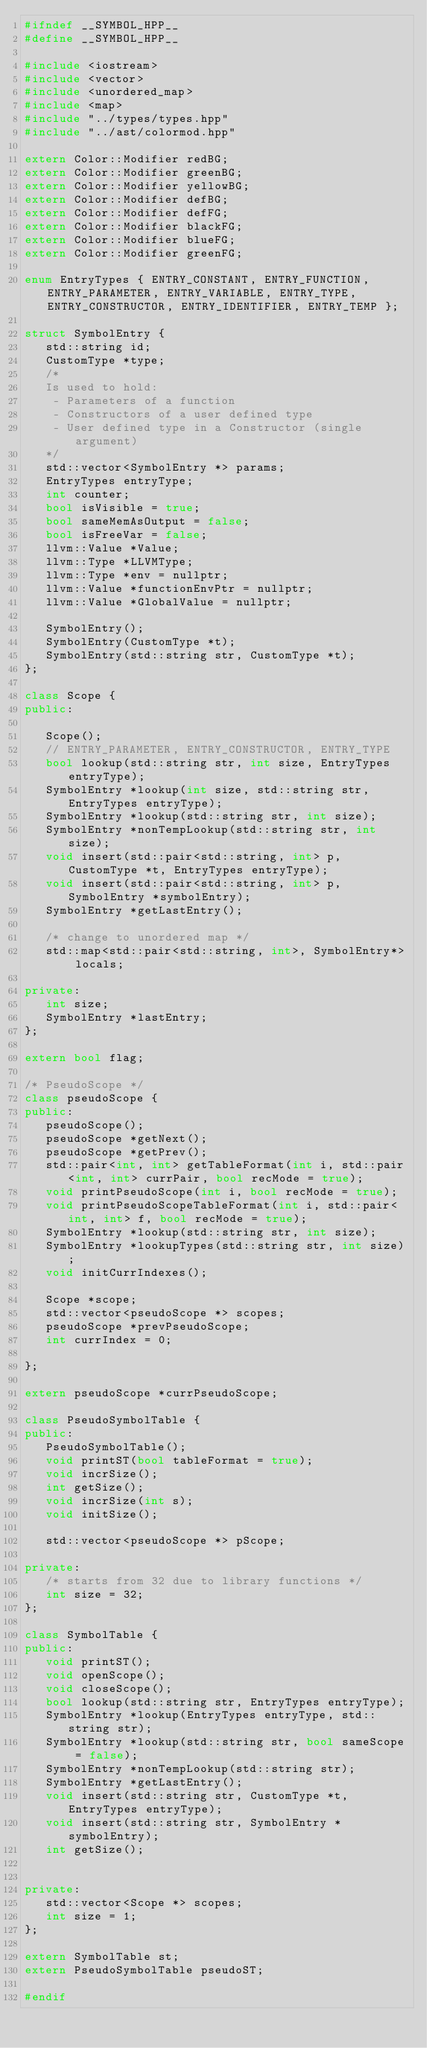<code> <loc_0><loc_0><loc_500><loc_500><_C++_>#ifndef __SYMBOL_HPP__
#define __SYMBOL_HPP__

#include <iostream>
#include <vector>
#include <unordered_map>
#include <map>
#include "../types/types.hpp"
#include "../ast/colormod.hpp"

extern Color::Modifier redBG;
extern Color::Modifier greenBG;
extern Color::Modifier yellowBG;
extern Color::Modifier defBG;
extern Color::Modifier defFG;
extern Color::Modifier blackFG;
extern Color::Modifier blueFG;
extern Color::Modifier greenFG;

enum EntryTypes { ENTRY_CONSTANT, ENTRY_FUNCTION, ENTRY_PARAMETER, ENTRY_VARIABLE, ENTRY_TYPE, ENTRY_CONSTRUCTOR, ENTRY_IDENTIFIER, ENTRY_TEMP };

struct SymbolEntry {
   std::string id;
   CustomType *type;
   /* 
   Is used to hold:
    - Parameters of a function
    - Constructors of a user defined type
    - User defined type in a Constructor (single argument)   
   */
   std::vector<SymbolEntry *> params;
   EntryTypes entryType;
   int counter;
   bool isVisible = true;
   bool sameMemAsOutput = false;
   bool isFreeVar = false;
   llvm::Value *Value;
   llvm::Type *LLVMType;
   llvm::Type *env = nullptr;
   llvm::Value *functionEnvPtr = nullptr;
   llvm::Value *GlobalValue = nullptr;

   SymbolEntry();
   SymbolEntry(CustomType *t);
   SymbolEntry(std::string str, CustomType *t);
};

class Scope {
public:

   Scope();
   // ENTRY_PARAMETER, ENTRY_CONSTRUCTOR, ENTRY_TYPE
   bool lookup(std::string str, int size, EntryTypes entryType);
   SymbolEntry *lookup(int size, std::string str, EntryTypes entryType);
   SymbolEntry *lookup(std::string str, int size);
   SymbolEntry *nonTempLookup(std::string str, int size);
   void insert(std::pair<std::string, int> p, CustomType *t, EntryTypes entryType);
   void insert(std::pair<std::string, int> p, SymbolEntry *symbolEntry);
   SymbolEntry *getLastEntry();

   /* change to unordered map */
   std::map<std::pair<std::string, int>, SymbolEntry*> locals;

private:
   int size;
   SymbolEntry *lastEntry;
};

extern bool flag;

/* PseudoScope */
class pseudoScope {
public:
   pseudoScope();
   pseudoScope *getNext();
   pseudoScope *getPrev();
   std::pair<int, int> getTableFormat(int i, std::pair<int, int> currPair, bool recMode = true);
   void printPseudoScope(int i, bool recMode = true);
   void printPseudoScopeTableFormat(int i, std::pair<int, int> f, bool recMode = true);
   SymbolEntry *lookup(std::string str, int size);
   SymbolEntry *lookupTypes(std::string str, int size);
   void initCurrIndexes();

   Scope *scope;
   std::vector<pseudoScope *> scopes;
   pseudoScope *prevPseudoScope;
   int currIndex = 0;

};

extern pseudoScope *currPseudoScope;

class PseudoSymbolTable {
public:
   PseudoSymbolTable();
   void printST(bool tableFormat = true);
   void incrSize();
   int getSize();
   void incrSize(int s);
   void initSize();

   std::vector<pseudoScope *> pScope;

private:
   /* starts from 32 due to library functions */
   int size = 32;
};

class SymbolTable {
public:
   void printST();
   void openScope();
   void closeScope();
   bool lookup(std::string str, EntryTypes entryType);
   SymbolEntry *lookup(EntryTypes entryType, std::string str);
   SymbolEntry *lookup(std::string str, bool sameScope = false);
   SymbolEntry *nonTempLookup(std::string str);
   SymbolEntry *getLastEntry();
   void insert(std::string str, CustomType *t, EntryTypes entryType);
   void insert(std::string str, SymbolEntry *symbolEntry);
   int getSize();


private:
   std::vector<Scope *> scopes;
   int size = 1;
};

extern SymbolTable st;
extern PseudoSymbolTable pseudoST;

#endif</code> 